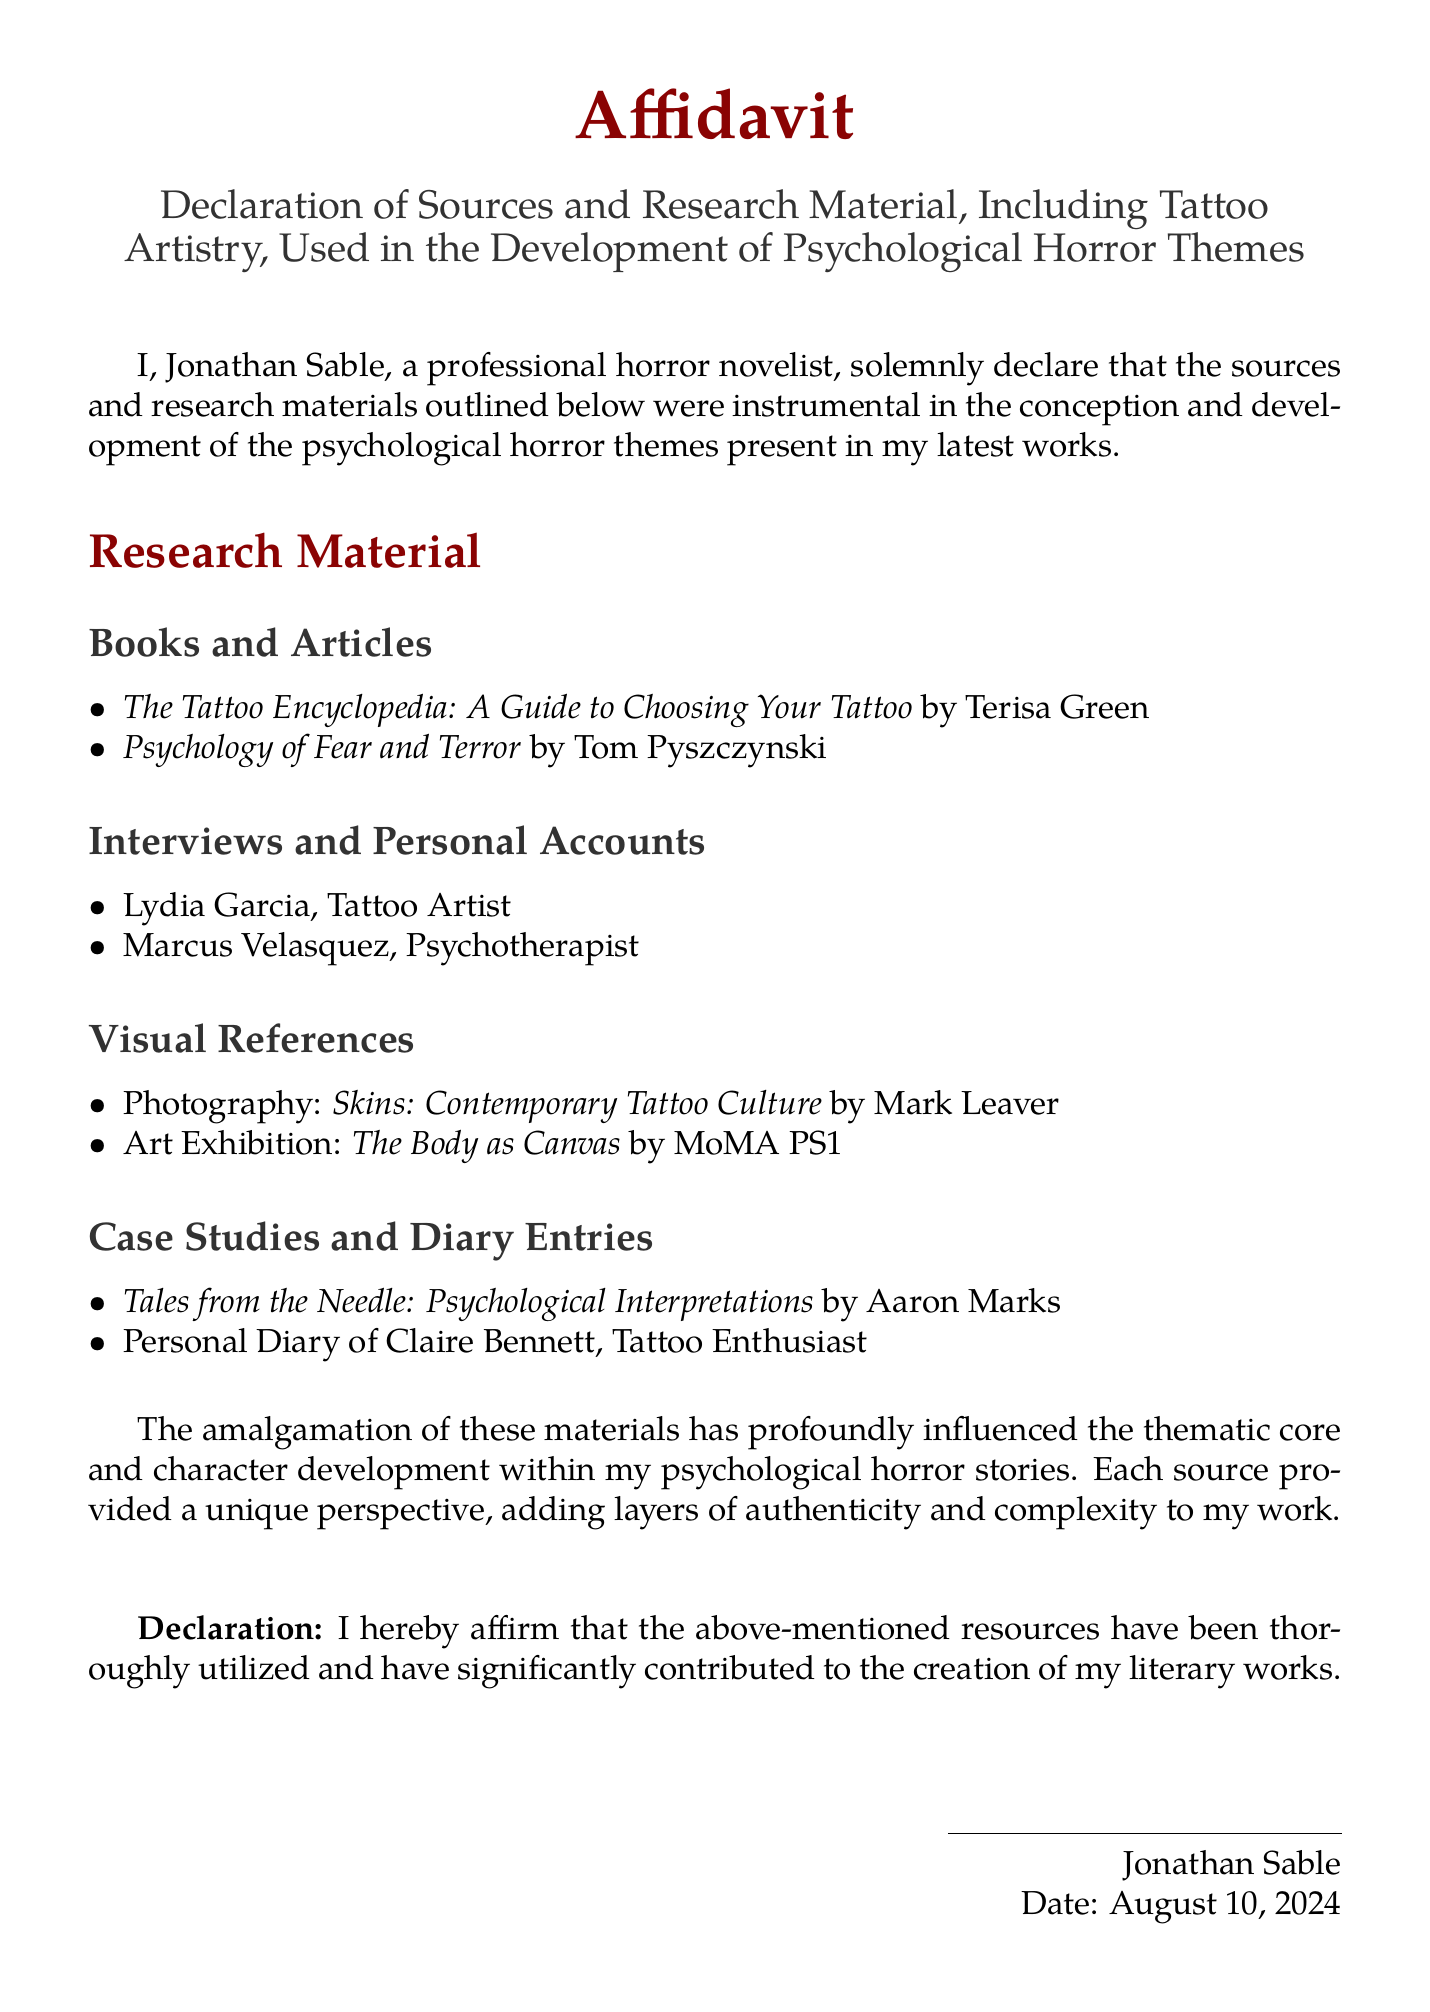What is the title of the document? The title is located at the beginning of the affidavit, specifying its purpose.
Answer: Affidavit Who is the author of the affidavit? The author's name is stated at the beginning of the document.
Answer: Jonathan Sable What is one of the books listed as research material? The document lists several books; this is asking for any single title mentioned.
Answer: The Tattoo Encyclopedia: A Guide to Choosing Your Tattoo Who conducted an interview featured in the affidavit? The affidavit mentions individuals who provided interviews and personal accounts.
Answer: Lydia Garcia What type of visual reference is mentioned in the document? This question looks for the category of visual references used in the research material.
Answer: Photography In what year was this affidavit likely created? The affidavit uses the command for the current date, which indicates when it was likely created.
Answer: 2023 What does the affidavit affirm in the declaration section? The declaration section of the document contains a statement about the use of resources.
Answer: Resources have been thoroughly utilized Who contributed to the psychological interpretations mentioned? The affidavit lists sources specifically related to psychological interpretations in tattoo culture.
Answer: Aaron Marks What does the title of the artwork exhibition suggest about the thematic exploration? This question seeks the implications of the title in relation to the content explored in the affidavit.
Answer: The Body as Canvas 